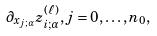Convert formula to latex. <formula><loc_0><loc_0><loc_500><loc_500>\partial _ { x _ { j ; \alpha } } z _ { i ; \alpha } ^ { ( \ell ) } , j = 0 , \dots , n _ { 0 } ,</formula> 